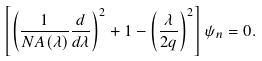Convert formula to latex. <formula><loc_0><loc_0><loc_500><loc_500>\left [ \left ( \frac { 1 } { N A ( \lambda ) } \frac { d } { d \lambda } \right ) ^ { 2 } + 1 - \left ( \frac { \lambda } { 2 q } \right ) ^ { 2 } \right ] \psi _ { n } = 0 .</formula> 